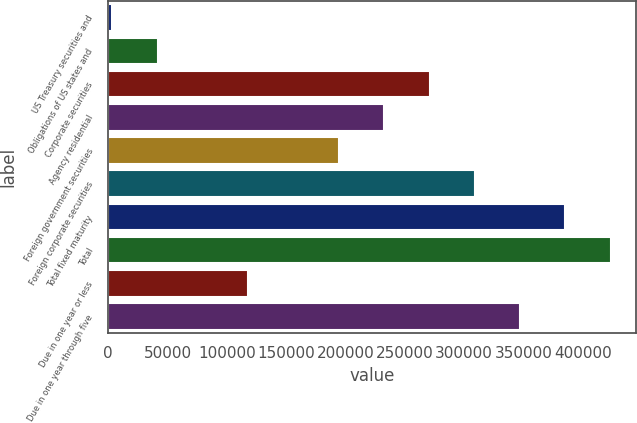<chart> <loc_0><loc_0><loc_500><loc_500><bar_chart><fcel>US Treasury securities and<fcel>Obligations of US states and<fcel>Corporate securities<fcel>Agency residential<fcel>Foreign government securities<fcel>Foreign corporate securities<fcel>Total fixed maturity<fcel>Total<fcel>Due in one year or less<fcel>Due in one year through five<nl><fcel>3386<fcel>41578.5<fcel>270734<fcel>232541<fcel>194348<fcel>308926<fcel>385311<fcel>423504<fcel>117964<fcel>347118<nl></chart> 